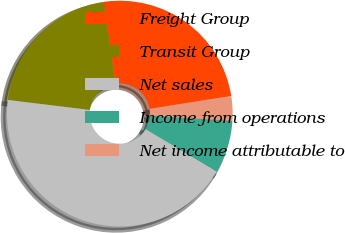<chart> <loc_0><loc_0><loc_500><loc_500><pie_chart><fcel>Freight Group<fcel>Transit Group<fcel>Net sales<fcel>Income from operations<fcel>Net income attributable to<nl><fcel>24.77%<fcel>20.79%<fcel>43.37%<fcel>7.52%<fcel>3.54%<nl></chart> 